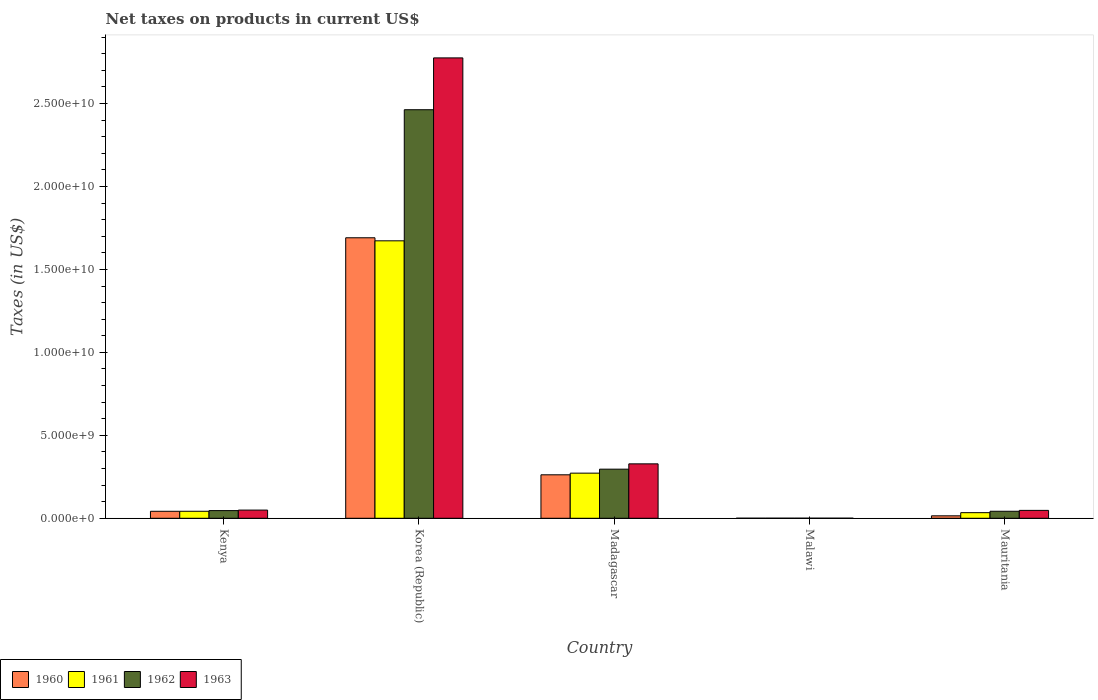How many groups of bars are there?
Provide a short and direct response. 5. Are the number of bars per tick equal to the number of legend labels?
Offer a terse response. Yes. Are the number of bars on each tick of the X-axis equal?
Give a very brief answer. Yes. How many bars are there on the 1st tick from the right?
Provide a short and direct response. 4. What is the label of the 1st group of bars from the left?
Your answer should be very brief. Kenya. In how many cases, is the number of bars for a given country not equal to the number of legend labels?
Provide a short and direct response. 0. What is the net taxes on products in 1963 in Malawi?
Make the answer very short. 4.60e+06. Across all countries, what is the maximum net taxes on products in 1962?
Give a very brief answer. 2.46e+1. Across all countries, what is the minimum net taxes on products in 1960?
Provide a succinct answer. 3.90e+06. In which country was the net taxes on products in 1960 minimum?
Your response must be concise. Malawi. What is the total net taxes on products in 1961 in the graph?
Ensure brevity in your answer.  2.02e+1. What is the difference between the net taxes on products in 1962 in Korea (Republic) and that in Malawi?
Make the answer very short. 2.46e+1. What is the difference between the net taxes on products in 1963 in Mauritania and the net taxes on products in 1961 in Malawi?
Make the answer very short. 4.71e+08. What is the average net taxes on products in 1963 per country?
Ensure brevity in your answer.  6.40e+09. In how many countries, is the net taxes on products in 1963 greater than 16000000000 US$?
Ensure brevity in your answer.  1. What is the ratio of the net taxes on products in 1962 in Madagascar to that in Malawi?
Your answer should be very brief. 672.74. Is the net taxes on products in 1962 in Madagascar less than that in Malawi?
Your answer should be very brief. No. Is the difference between the net taxes on products in 1962 in Kenya and Mauritania greater than the difference between the net taxes on products in 1963 in Kenya and Mauritania?
Your response must be concise. Yes. What is the difference between the highest and the second highest net taxes on products in 1963?
Provide a short and direct response. 2.73e+1. What is the difference between the highest and the lowest net taxes on products in 1961?
Ensure brevity in your answer.  1.67e+1. What does the 3rd bar from the right in Malawi represents?
Give a very brief answer. 1961. Is it the case that in every country, the sum of the net taxes on products in 1963 and net taxes on products in 1962 is greater than the net taxes on products in 1960?
Give a very brief answer. Yes. How many bars are there?
Your answer should be compact. 20. How many countries are there in the graph?
Give a very brief answer. 5. Are the values on the major ticks of Y-axis written in scientific E-notation?
Offer a very short reply. Yes. Does the graph contain any zero values?
Provide a succinct answer. No. Does the graph contain grids?
Provide a short and direct response. No. Where does the legend appear in the graph?
Keep it short and to the point. Bottom left. How many legend labels are there?
Give a very brief answer. 4. What is the title of the graph?
Provide a succinct answer. Net taxes on products in current US$. Does "1996" appear as one of the legend labels in the graph?
Make the answer very short. No. What is the label or title of the Y-axis?
Provide a succinct answer. Taxes (in US$). What is the Taxes (in US$) of 1960 in Kenya?
Your response must be concise. 4.21e+08. What is the Taxes (in US$) in 1961 in Kenya?
Keep it short and to the point. 4.22e+08. What is the Taxes (in US$) in 1962 in Kenya?
Offer a terse response. 4.62e+08. What is the Taxes (in US$) in 1963 in Kenya?
Offer a very short reply. 4.93e+08. What is the Taxes (in US$) of 1960 in Korea (Republic)?
Give a very brief answer. 1.69e+1. What is the Taxes (in US$) of 1961 in Korea (Republic)?
Offer a terse response. 1.67e+1. What is the Taxes (in US$) in 1962 in Korea (Republic)?
Offer a terse response. 2.46e+1. What is the Taxes (in US$) in 1963 in Korea (Republic)?
Keep it short and to the point. 2.77e+1. What is the Taxes (in US$) of 1960 in Madagascar?
Offer a terse response. 2.62e+09. What is the Taxes (in US$) of 1961 in Madagascar?
Offer a very short reply. 2.72e+09. What is the Taxes (in US$) in 1962 in Madagascar?
Offer a very short reply. 2.96e+09. What is the Taxes (in US$) in 1963 in Madagascar?
Keep it short and to the point. 3.28e+09. What is the Taxes (in US$) of 1960 in Malawi?
Provide a succinct answer. 3.90e+06. What is the Taxes (in US$) in 1961 in Malawi?
Provide a short and direct response. 4.20e+06. What is the Taxes (in US$) of 1962 in Malawi?
Your answer should be very brief. 4.40e+06. What is the Taxes (in US$) of 1963 in Malawi?
Make the answer very short. 4.60e+06. What is the Taxes (in US$) in 1960 in Mauritania?
Offer a terse response. 1.48e+08. What is the Taxes (in US$) of 1961 in Mauritania?
Your answer should be very brief. 3.38e+08. What is the Taxes (in US$) in 1962 in Mauritania?
Ensure brevity in your answer.  4.23e+08. What is the Taxes (in US$) of 1963 in Mauritania?
Your answer should be very brief. 4.75e+08. Across all countries, what is the maximum Taxes (in US$) in 1960?
Your answer should be very brief. 1.69e+1. Across all countries, what is the maximum Taxes (in US$) in 1961?
Offer a very short reply. 1.67e+1. Across all countries, what is the maximum Taxes (in US$) of 1962?
Keep it short and to the point. 2.46e+1. Across all countries, what is the maximum Taxes (in US$) in 1963?
Offer a very short reply. 2.77e+1. Across all countries, what is the minimum Taxes (in US$) in 1960?
Your response must be concise. 3.90e+06. Across all countries, what is the minimum Taxes (in US$) of 1961?
Make the answer very short. 4.20e+06. Across all countries, what is the minimum Taxes (in US$) of 1962?
Make the answer very short. 4.40e+06. Across all countries, what is the minimum Taxes (in US$) of 1963?
Give a very brief answer. 4.60e+06. What is the total Taxes (in US$) of 1960 in the graph?
Offer a very short reply. 2.01e+1. What is the total Taxes (in US$) in 1961 in the graph?
Provide a succinct answer. 2.02e+1. What is the total Taxes (in US$) in 1962 in the graph?
Give a very brief answer. 2.85e+1. What is the total Taxes (in US$) of 1963 in the graph?
Give a very brief answer. 3.20e+1. What is the difference between the Taxes (in US$) of 1960 in Kenya and that in Korea (Republic)?
Offer a very short reply. -1.65e+1. What is the difference between the Taxes (in US$) in 1961 in Kenya and that in Korea (Republic)?
Provide a short and direct response. -1.63e+1. What is the difference between the Taxes (in US$) of 1962 in Kenya and that in Korea (Republic)?
Ensure brevity in your answer.  -2.42e+1. What is the difference between the Taxes (in US$) of 1963 in Kenya and that in Korea (Republic)?
Ensure brevity in your answer.  -2.73e+1. What is the difference between the Taxes (in US$) of 1960 in Kenya and that in Madagascar?
Your answer should be very brief. -2.20e+09. What is the difference between the Taxes (in US$) of 1961 in Kenya and that in Madagascar?
Your answer should be very brief. -2.30e+09. What is the difference between the Taxes (in US$) of 1962 in Kenya and that in Madagascar?
Your answer should be very brief. -2.50e+09. What is the difference between the Taxes (in US$) in 1963 in Kenya and that in Madagascar?
Offer a terse response. -2.79e+09. What is the difference between the Taxes (in US$) of 1960 in Kenya and that in Malawi?
Offer a very short reply. 4.17e+08. What is the difference between the Taxes (in US$) of 1961 in Kenya and that in Malawi?
Give a very brief answer. 4.18e+08. What is the difference between the Taxes (in US$) of 1962 in Kenya and that in Malawi?
Offer a very short reply. 4.57e+08. What is the difference between the Taxes (in US$) in 1963 in Kenya and that in Malawi?
Offer a terse response. 4.88e+08. What is the difference between the Taxes (in US$) in 1960 in Kenya and that in Mauritania?
Provide a succinct answer. 2.73e+08. What is the difference between the Taxes (in US$) of 1961 in Kenya and that in Mauritania?
Provide a succinct answer. 8.39e+07. What is the difference between the Taxes (in US$) of 1962 in Kenya and that in Mauritania?
Offer a terse response. 3.92e+07. What is the difference between the Taxes (in US$) in 1963 in Kenya and that in Mauritania?
Provide a succinct answer. 1.76e+07. What is the difference between the Taxes (in US$) of 1960 in Korea (Republic) and that in Madagascar?
Offer a terse response. 1.43e+1. What is the difference between the Taxes (in US$) in 1961 in Korea (Republic) and that in Madagascar?
Your answer should be very brief. 1.40e+1. What is the difference between the Taxes (in US$) of 1962 in Korea (Republic) and that in Madagascar?
Keep it short and to the point. 2.17e+1. What is the difference between the Taxes (in US$) of 1963 in Korea (Republic) and that in Madagascar?
Ensure brevity in your answer.  2.45e+1. What is the difference between the Taxes (in US$) of 1960 in Korea (Republic) and that in Malawi?
Ensure brevity in your answer.  1.69e+1. What is the difference between the Taxes (in US$) of 1961 in Korea (Republic) and that in Malawi?
Offer a very short reply. 1.67e+1. What is the difference between the Taxes (in US$) in 1962 in Korea (Republic) and that in Malawi?
Ensure brevity in your answer.  2.46e+1. What is the difference between the Taxes (in US$) in 1963 in Korea (Republic) and that in Malawi?
Provide a succinct answer. 2.77e+1. What is the difference between the Taxes (in US$) of 1960 in Korea (Republic) and that in Mauritania?
Ensure brevity in your answer.  1.68e+1. What is the difference between the Taxes (in US$) in 1961 in Korea (Republic) and that in Mauritania?
Provide a short and direct response. 1.64e+1. What is the difference between the Taxes (in US$) in 1962 in Korea (Republic) and that in Mauritania?
Ensure brevity in your answer.  2.42e+1. What is the difference between the Taxes (in US$) of 1963 in Korea (Republic) and that in Mauritania?
Offer a very short reply. 2.73e+1. What is the difference between the Taxes (in US$) of 1960 in Madagascar and that in Malawi?
Make the answer very short. 2.62e+09. What is the difference between the Taxes (in US$) of 1961 in Madagascar and that in Malawi?
Keep it short and to the point. 2.72e+09. What is the difference between the Taxes (in US$) of 1962 in Madagascar and that in Malawi?
Provide a short and direct response. 2.96e+09. What is the difference between the Taxes (in US$) of 1963 in Madagascar and that in Malawi?
Ensure brevity in your answer.  3.28e+09. What is the difference between the Taxes (in US$) in 1960 in Madagascar and that in Mauritania?
Provide a short and direct response. 2.47e+09. What is the difference between the Taxes (in US$) of 1961 in Madagascar and that in Mauritania?
Your answer should be very brief. 2.38e+09. What is the difference between the Taxes (in US$) of 1962 in Madagascar and that in Mauritania?
Offer a very short reply. 2.54e+09. What is the difference between the Taxes (in US$) of 1963 in Madagascar and that in Mauritania?
Give a very brief answer. 2.80e+09. What is the difference between the Taxes (in US$) of 1960 in Malawi and that in Mauritania?
Ensure brevity in your answer.  -1.44e+08. What is the difference between the Taxes (in US$) in 1961 in Malawi and that in Mauritania?
Give a very brief answer. -3.34e+08. What is the difference between the Taxes (in US$) of 1962 in Malawi and that in Mauritania?
Ensure brevity in your answer.  -4.18e+08. What is the difference between the Taxes (in US$) of 1963 in Malawi and that in Mauritania?
Your answer should be compact. -4.71e+08. What is the difference between the Taxes (in US$) in 1960 in Kenya and the Taxes (in US$) in 1961 in Korea (Republic)?
Keep it short and to the point. -1.63e+1. What is the difference between the Taxes (in US$) in 1960 in Kenya and the Taxes (in US$) in 1962 in Korea (Republic)?
Your response must be concise. -2.42e+1. What is the difference between the Taxes (in US$) of 1960 in Kenya and the Taxes (in US$) of 1963 in Korea (Republic)?
Keep it short and to the point. -2.73e+1. What is the difference between the Taxes (in US$) in 1961 in Kenya and the Taxes (in US$) in 1962 in Korea (Republic)?
Provide a succinct answer. -2.42e+1. What is the difference between the Taxes (in US$) in 1961 in Kenya and the Taxes (in US$) in 1963 in Korea (Republic)?
Offer a terse response. -2.73e+1. What is the difference between the Taxes (in US$) in 1962 in Kenya and the Taxes (in US$) in 1963 in Korea (Republic)?
Your answer should be compact. -2.73e+1. What is the difference between the Taxes (in US$) in 1960 in Kenya and the Taxes (in US$) in 1961 in Madagascar?
Ensure brevity in your answer.  -2.30e+09. What is the difference between the Taxes (in US$) in 1960 in Kenya and the Taxes (in US$) in 1962 in Madagascar?
Offer a very short reply. -2.54e+09. What is the difference between the Taxes (in US$) of 1960 in Kenya and the Taxes (in US$) of 1963 in Madagascar?
Give a very brief answer. -2.86e+09. What is the difference between the Taxes (in US$) in 1961 in Kenya and the Taxes (in US$) in 1962 in Madagascar?
Provide a short and direct response. -2.54e+09. What is the difference between the Taxes (in US$) in 1961 in Kenya and the Taxes (in US$) in 1963 in Madagascar?
Offer a terse response. -2.86e+09. What is the difference between the Taxes (in US$) in 1962 in Kenya and the Taxes (in US$) in 1963 in Madagascar?
Your response must be concise. -2.82e+09. What is the difference between the Taxes (in US$) in 1960 in Kenya and the Taxes (in US$) in 1961 in Malawi?
Offer a very short reply. 4.17e+08. What is the difference between the Taxes (in US$) in 1960 in Kenya and the Taxes (in US$) in 1962 in Malawi?
Make the answer very short. 4.16e+08. What is the difference between the Taxes (in US$) of 1960 in Kenya and the Taxes (in US$) of 1963 in Malawi?
Your answer should be very brief. 4.16e+08. What is the difference between the Taxes (in US$) of 1961 in Kenya and the Taxes (in US$) of 1962 in Malawi?
Provide a short and direct response. 4.18e+08. What is the difference between the Taxes (in US$) of 1961 in Kenya and the Taxes (in US$) of 1963 in Malawi?
Your response must be concise. 4.17e+08. What is the difference between the Taxes (in US$) of 1962 in Kenya and the Taxes (in US$) of 1963 in Malawi?
Your response must be concise. 4.57e+08. What is the difference between the Taxes (in US$) of 1960 in Kenya and the Taxes (in US$) of 1961 in Mauritania?
Your answer should be compact. 8.29e+07. What is the difference between the Taxes (in US$) of 1960 in Kenya and the Taxes (in US$) of 1962 in Mauritania?
Ensure brevity in your answer.  -1.66e+06. What is the difference between the Taxes (in US$) in 1960 in Kenya and the Taxes (in US$) in 1963 in Mauritania?
Provide a succinct answer. -5.45e+07. What is the difference between the Taxes (in US$) in 1961 in Kenya and the Taxes (in US$) in 1962 in Mauritania?
Keep it short and to the point. -6.60e+05. What is the difference between the Taxes (in US$) in 1961 in Kenya and the Taxes (in US$) in 1963 in Mauritania?
Your answer should be compact. -5.35e+07. What is the difference between the Taxes (in US$) of 1962 in Kenya and the Taxes (in US$) of 1963 in Mauritania?
Offer a very short reply. -1.36e+07. What is the difference between the Taxes (in US$) of 1960 in Korea (Republic) and the Taxes (in US$) of 1961 in Madagascar?
Keep it short and to the point. 1.42e+1. What is the difference between the Taxes (in US$) of 1960 in Korea (Republic) and the Taxes (in US$) of 1962 in Madagascar?
Give a very brief answer. 1.39e+1. What is the difference between the Taxes (in US$) of 1960 in Korea (Republic) and the Taxes (in US$) of 1963 in Madagascar?
Your answer should be compact. 1.36e+1. What is the difference between the Taxes (in US$) in 1961 in Korea (Republic) and the Taxes (in US$) in 1962 in Madagascar?
Keep it short and to the point. 1.38e+1. What is the difference between the Taxes (in US$) in 1961 in Korea (Republic) and the Taxes (in US$) in 1963 in Madagascar?
Provide a short and direct response. 1.34e+1. What is the difference between the Taxes (in US$) in 1962 in Korea (Republic) and the Taxes (in US$) in 1963 in Madagascar?
Keep it short and to the point. 2.13e+1. What is the difference between the Taxes (in US$) in 1960 in Korea (Republic) and the Taxes (in US$) in 1961 in Malawi?
Give a very brief answer. 1.69e+1. What is the difference between the Taxes (in US$) of 1960 in Korea (Republic) and the Taxes (in US$) of 1962 in Malawi?
Your answer should be very brief. 1.69e+1. What is the difference between the Taxes (in US$) in 1960 in Korea (Republic) and the Taxes (in US$) in 1963 in Malawi?
Give a very brief answer. 1.69e+1. What is the difference between the Taxes (in US$) in 1961 in Korea (Republic) and the Taxes (in US$) in 1962 in Malawi?
Provide a short and direct response. 1.67e+1. What is the difference between the Taxes (in US$) in 1961 in Korea (Republic) and the Taxes (in US$) in 1963 in Malawi?
Your answer should be compact. 1.67e+1. What is the difference between the Taxes (in US$) in 1962 in Korea (Republic) and the Taxes (in US$) in 1963 in Malawi?
Keep it short and to the point. 2.46e+1. What is the difference between the Taxes (in US$) in 1960 in Korea (Republic) and the Taxes (in US$) in 1961 in Mauritania?
Your answer should be compact. 1.66e+1. What is the difference between the Taxes (in US$) of 1960 in Korea (Republic) and the Taxes (in US$) of 1962 in Mauritania?
Offer a very short reply. 1.65e+1. What is the difference between the Taxes (in US$) in 1960 in Korea (Republic) and the Taxes (in US$) in 1963 in Mauritania?
Provide a succinct answer. 1.64e+1. What is the difference between the Taxes (in US$) in 1961 in Korea (Republic) and the Taxes (in US$) in 1962 in Mauritania?
Your answer should be compact. 1.63e+1. What is the difference between the Taxes (in US$) in 1961 in Korea (Republic) and the Taxes (in US$) in 1963 in Mauritania?
Keep it short and to the point. 1.62e+1. What is the difference between the Taxes (in US$) in 1962 in Korea (Republic) and the Taxes (in US$) in 1963 in Mauritania?
Keep it short and to the point. 2.42e+1. What is the difference between the Taxes (in US$) of 1960 in Madagascar and the Taxes (in US$) of 1961 in Malawi?
Provide a succinct answer. 2.62e+09. What is the difference between the Taxes (in US$) in 1960 in Madagascar and the Taxes (in US$) in 1962 in Malawi?
Your response must be concise. 2.62e+09. What is the difference between the Taxes (in US$) in 1960 in Madagascar and the Taxes (in US$) in 1963 in Malawi?
Your answer should be very brief. 2.62e+09. What is the difference between the Taxes (in US$) of 1961 in Madagascar and the Taxes (in US$) of 1962 in Malawi?
Your answer should be very brief. 2.72e+09. What is the difference between the Taxes (in US$) in 1961 in Madagascar and the Taxes (in US$) in 1963 in Malawi?
Provide a short and direct response. 2.72e+09. What is the difference between the Taxes (in US$) of 1962 in Madagascar and the Taxes (in US$) of 1963 in Malawi?
Your answer should be very brief. 2.96e+09. What is the difference between the Taxes (in US$) of 1960 in Madagascar and the Taxes (in US$) of 1961 in Mauritania?
Give a very brief answer. 2.28e+09. What is the difference between the Taxes (in US$) of 1960 in Madagascar and the Taxes (in US$) of 1962 in Mauritania?
Make the answer very short. 2.20e+09. What is the difference between the Taxes (in US$) in 1960 in Madagascar and the Taxes (in US$) in 1963 in Mauritania?
Make the answer very short. 2.14e+09. What is the difference between the Taxes (in US$) of 1961 in Madagascar and the Taxes (in US$) of 1962 in Mauritania?
Keep it short and to the point. 2.30e+09. What is the difference between the Taxes (in US$) in 1961 in Madagascar and the Taxes (in US$) in 1963 in Mauritania?
Your answer should be very brief. 2.24e+09. What is the difference between the Taxes (in US$) of 1962 in Madagascar and the Taxes (in US$) of 1963 in Mauritania?
Offer a very short reply. 2.48e+09. What is the difference between the Taxes (in US$) in 1960 in Malawi and the Taxes (in US$) in 1961 in Mauritania?
Your answer should be very brief. -3.34e+08. What is the difference between the Taxes (in US$) in 1960 in Malawi and the Taxes (in US$) in 1962 in Mauritania?
Offer a terse response. -4.19e+08. What is the difference between the Taxes (in US$) in 1960 in Malawi and the Taxes (in US$) in 1963 in Mauritania?
Offer a very short reply. -4.71e+08. What is the difference between the Taxes (in US$) in 1961 in Malawi and the Taxes (in US$) in 1962 in Mauritania?
Your answer should be compact. -4.18e+08. What is the difference between the Taxes (in US$) in 1961 in Malawi and the Taxes (in US$) in 1963 in Mauritania?
Ensure brevity in your answer.  -4.71e+08. What is the difference between the Taxes (in US$) of 1962 in Malawi and the Taxes (in US$) of 1963 in Mauritania?
Provide a succinct answer. -4.71e+08. What is the average Taxes (in US$) of 1960 per country?
Your answer should be very brief. 4.02e+09. What is the average Taxes (in US$) of 1961 per country?
Make the answer very short. 4.04e+09. What is the average Taxes (in US$) of 1962 per country?
Ensure brevity in your answer.  5.69e+09. What is the average Taxes (in US$) of 1963 per country?
Your answer should be compact. 6.40e+09. What is the difference between the Taxes (in US$) in 1960 and Taxes (in US$) in 1962 in Kenya?
Make the answer very short. -4.09e+07. What is the difference between the Taxes (in US$) of 1960 and Taxes (in US$) of 1963 in Kenya?
Provide a succinct answer. -7.21e+07. What is the difference between the Taxes (in US$) of 1961 and Taxes (in US$) of 1962 in Kenya?
Provide a short and direct response. -3.99e+07. What is the difference between the Taxes (in US$) of 1961 and Taxes (in US$) of 1963 in Kenya?
Your response must be concise. -7.11e+07. What is the difference between the Taxes (in US$) of 1962 and Taxes (in US$) of 1963 in Kenya?
Your answer should be compact. -3.12e+07. What is the difference between the Taxes (in US$) of 1960 and Taxes (in US$) of 1961 in Korea (Republic)?
Provide a succinct answer. 1.84e+08. What is the difference between the Taxes (in US$) of 1960 and Taxes (in US$) of 1962 in Korea (Republic)?
Give a very brief answer. -7.72e+09. What is the difference between the Taxes (in US$) of 1960 and Taxes (in US$) of 1963 in Korea (Republic)?
Your answer should be compact. -1.08e+1. What is the difference between the Taxes (in US$) in 1961 and Taxes (in US$) in 1962 in Korea (Republic)?
Your response must be concise. -7.90e+09. What is the difference between the Taxes (in US$) in 1961 and Taxes (in US$) in 1963 in Korea (Republic)?
Offer a very short reply. -1.10e+1. What is the difference between the Taxes (in US$) of 1962 and Taxes (in US$) of 1963 in Korea (Republic)?
Ensure brevity in your answer.  -3.12e+09. What is the difference between the Taxes (in US$) of 1960 and Taxes (in US$) of 1961 in Madagascar?
Your answer should be very brief. -1.00e+08. What is the difference between the Taxes (in US$) of 1960 and Taxes (in US$) of 1962 in Madagascar?
Provide a succinct answer. -3.40e+08. What is the difference between the Taxes (in US$) in 1960 and Taxes (in US$) in 1963 in Madagascar?
Offer a very short reply. -6.60e+08. What is the difference between the Taxes (in US$) of 1961 and Taxes (in US$) of 1962 in Madagascar?
Provide a short and direct response. -2.40e+08. What is the difference between the Taxes (in US$) in 1961 and Taxes (in US$) in 1963 in Madagascar?
Provide a succinct answer. -5.60e+08. What is the difference between the Taxes (in US$) of 1962 and Taxes (in US$) of 1963 in Madagascar?
Ensure brevity in your answer.  -3.20e+08. What is the difference between the Taxes (in US$) of 1960 and Taxes (in US$) of 1961 in Malawi?
Ensure brevity in your answer.  -3.00e+05. What is the difference between the Taxes (in US$) in 1960 and Taxes (in US$) in 1962 in Malawi?
Your answer should be very brief. -5.00e+05. What is the difference between the Taxes (in US$) of 1960 and Taxes (in US$) of 1963 in Malawi?
Give a very brief answer. -7.00e+05. What is the difference between the Taxes (in US$) of 1961 and Taxes (in US$) of 1963 in Malawi?
Offer a very short reply. -4.00e+05. What is the difference between the Taxes (in US$) of 1960 and Taxes (in US$) of 1961 in Mauritania?
Offer a terse response. -1.90e+08. What is the difference between the Taxes (in US$) in 1960 and Taxes (in US$) in 1962 in Mauritania?
Offer a terse response. -2.75e+08. What is the difference between the Taxes (in US$) of 1960 and Taxes (in US$) of 1963 in Mauritania?
Provide a succinct answer. -3.27e+08. What is the difference between the Taxes (in US$) of 1961 and Taxes (in US$) of 1962 in Mauritania?
Your response must be concise. -8.45e+07. What is the difference between the Taxes (in US$) of 1961 and Taxes (in US$) of 1963 in Mauritania?
Give a very brief answer. -1.37e+08. What is the difference between the Taxes (in US$) in 1962 and Taxes (in US$) in 1963 in Mauritania?
Make the answer very short. -5.28e+07. What is the ratio of the Taxes (in US$) of 1960 in Kenya to that in Korea (Republic)?
Provide a short and direct response. 0.02. What is the ratio of the Taxes (in US$) in 1961 in Kenya to that in Korea (Republic)?
Offer a terse response. 0.03. What is the ratio of the Taxes (in US$) of 1962 in Kenya to that in Korea (Republic)?
Ensure brevity in your answer.  0.02. What is the ratio of the Taxes (in US$) in 1963 in Kenya to that in Korea (Republic)?
Provide a short and direct response. 0.02. What is the ratio of the Taxes (in US$) in 1960 in Kenya to that in Madagascar?
Make the answer very short. 0.16. What is the ratio of the Taxes (in US$) of 1961 in Kenya to that in Madagascar?
Your answer should be compact. 0.16. What is the ratio of the Taxes (in US$) in 1962 in Kenya to that in Madagascar?
Your answer should be very brief. 0.16. What is the ratio of the Taxes (in US$) of 1963 in Kenya to that in Madagascar?
Offer a very short reply. 0.15. What is the ratio of the Taxes (in US$) of 1960 in Kenya to that in Malawi?
Provide a succinct answer. 107.92. What is the ratio of the Taxes (in US$) of 1961 in Kenya to that in Malawi?
Your response must be concise. 100.45. What is the ratio of the Taxes (in US$) of 1962 in Kenya to that in Malawi?
Offer a terse response. 104.95. What is the ratio of the Taxes (in US$) in 1963 in Kenya to that in Malawi?
Keep it short and to the point. 107.17. What is the ratio of the Taxes (in US$) in 1960 in Kenya to that in Mauritania?
Your answer should be very brief. 2.85. What is the ratio of the Taxes (in US$) of 1961 in Kenya to that in Mauritania?
Your response must be concise. 1.25. What is the ratio of the Taxes (in US$) of 1962 in Kenya to that in Mauritania?
Provide a short and direct response. 1.09. What is the ratio of the Taxes (in US$) of 1963 in Kenya to that in Mauritania?
Offer a very short reply. 1.04. What is the ratio of the Taxes (in US$) of 1960 in Korea (Republic) to that in Madagascar?
Provide a succinct answer. 6.45. What is the ratio of the Taxes (in US$) in 1961 in Korea (Republic) to that in Madagascar?
Provide a succinct answer. 6.15. What is the ratio of the Taxes (in US$) of 1962 in Korea (Republic) to that in Madagascar?
Offer a terse response. 8.32. What is the ratio of the Taxes (in US$) in 1963 in Korea (Republic) to that in Madagascar?
Offer a terse response. 8.46. What is the ratio of the Taxes (in US$) of 1960 in Korea (Republic) to that in Malawi?
Provide a succinct answer. 4335.16. What is the ratio of the Taxes (in US$) of 1961 in Korea (Republic) to that in Malawi?
Provide a succinct answer. 3981.75. What is the ratio of the Taxes (in US$) in 1962 in Korea (Republic) to that in Malawi?
Make the answer very short. 5596.72. What is the ratio of the Taxes (in US$) of 1963 in Korea (Republic) to that in Malawi?
Your answer should be very brief. 6032.55. What is the ratio of the Taxes (in US$) of 1960 in Korea (Republic) to that in Mauritania?
Give a very brief answer. 114.32. What is the ratio of the Taxes (in US$) of 1961 in Korea (Republic) to that in Mauritania?
Provide a succinct answer. 49.47. What is the ratio of the Taxes (in US$) in 1962 in Korea (Republic) to that in Mauritania?
Provide a succinct answer. 58.28. What is the ratio of the Taxes (in US$) in 1963 in Korea (Republic) to that in Mauritania?
Ensure brevity in your answer.  58.37. What is the ratio of the Taxes (in US$) in 1960 in Madagascar to that in Malawi?
Your answer should be compact. 671.81. What is the ratio of the Taxes (in US$) of 1961 in Madagascar to that in Malawi?
Offer a terse response. 647.63. What is the ratio of the Taxes (in US$) in 1962 in Madagascar to that in Malawi?
Your answer should be compact. 672.74. What is the ratio of the Taxes (in US$) of 1963 in Madagascar to that in Malawi?
Give a very brief answer. 713.06. What is the ratio of the Taxes (in US$) of 1960 in Madagascar to that in Mauritania?
Offer a terse response. 17.72. What is the ratio of the Taxes (in US$) of 1961 in Madagascar to that in Mauritania?
Your answer should be compact. 8.05. What is the ratio of the Taxes (in US$) in 1962 in Madagascar to that in Mauritania?
Your answer should be very brief. 7.01. What is the ratio of the Taxes (in US$) of 1963 in Madagascar to that in Mauritania?
Make the answer very short. 6.9. What is the ratio of the Taxes (in US$) in 1960 in Malawi to that in Mauritania?
Offer a terse response. 0.03. What is the ratio of the Taxes (in US$) in 1961 in Malawi to that in Mauritania?
Provide a short and direct response. 0.01. What is the ratio of the Taxes (in US$) of 1962 in Malawi to that in Mauritania?
Your answer should be very brief. 0.01. What is the ratio of the Taxes (in US$) in 1963 in Malawi to that in Mauritania?
Make the answer very short. 0.01. What is the difference between the highest and the second highest Taxes (in US$) of 1960?
Give a very brief answer. 1.43e+1. What is the difference between the highest and the second highest Taxes (in US$) in 1961?
Make the answer very short. 1.40e+1. What is the difference between the highest and the second highest Taxes (in US$) in 1962?
Your answer should be compact. 2.17e+1. What is the difference between the highest and the second highest Taxes (in US$) in 1963?
Your response must be concise. 2.45e+1. What is the difference between the highest and the lowest Taxes (in US$) in 1960?
Your response must be concise. 1.69e+1. What is the difference between the highest and the lowest Taxes (in US$) of 1961?
Make the answer very short. 1.67e+1. What is the difference between the highest and the lowest Taxes (in US$) in 1962?
Give a very brief answer. 2.46e+1. What is the difference between the highest and the lowest Taxes (in US$) of 1963?
Give a very brief answer. 2.77e+1. 